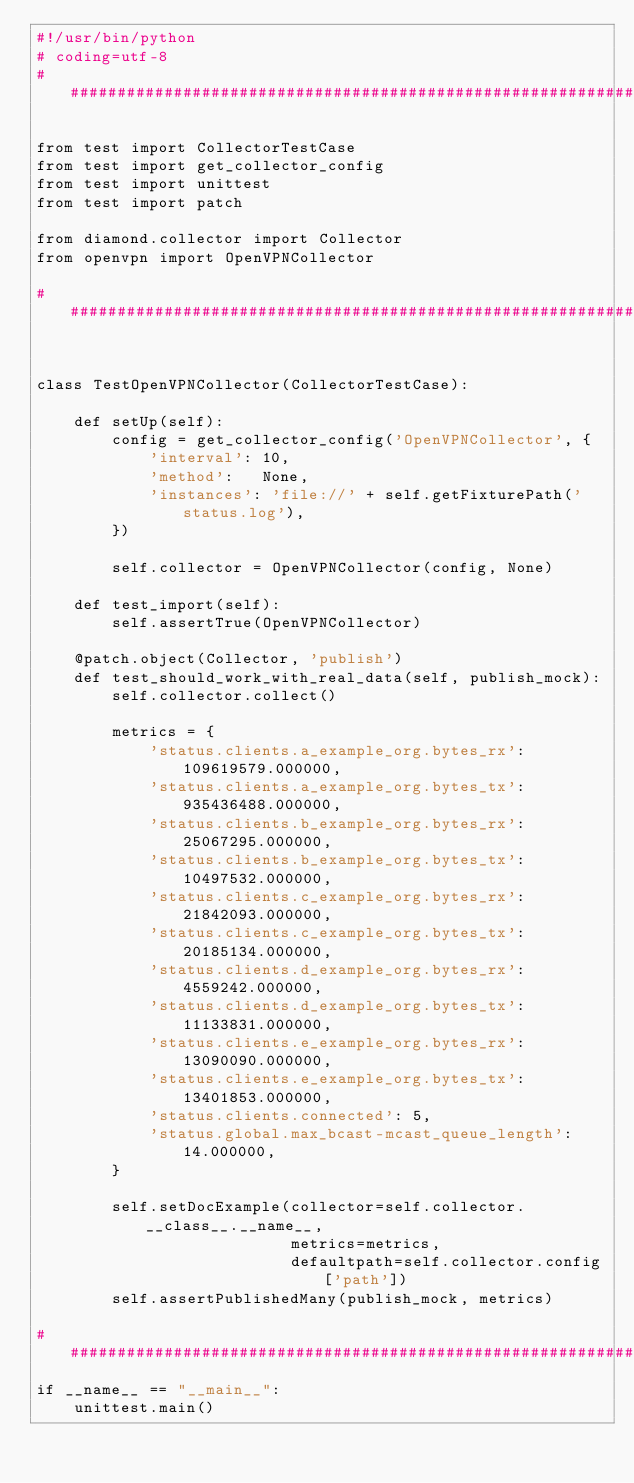<code> <loc_0><loc_0><loc_500><loc_500><_Python_>#!/usr/bin/python
# coding=utf-8
##########################################################################

from test import CollectorTestCase
from test import get_collector_config
from test import unittest
from test import patch

from diamond.collector import Collector
from openvpn import OpenVPNCollector

##########################################################################


class TestOpenVPNCollector(CollectorTestCase):

    def setUp(self):
        config = get_collector_config('OpenVPNCollector', {
            'interval': 10,
            'method':   None,
            'instances': 'file://' + self.getFixturePath('status.log'),
        })

        self.collector = OpenVPNCollector(config, None)

    def test_import(self):
        self.assertTrue(OpenVPNCollector)

    @patch.object(Collector, 'publish')
    def test_should_work_with_real_data(self, publish_mock):
        self.collector.collect()

        metrics = {
            'status.clients.a_example_org.bytes_rx': 109619579.000000,
            'status.clients.a_example_org.bytes_tx': 935436488.000000,
            'status.clients.b_example_org.bytes_rx': 25067295.000000,
            'status.clients.b_example_org.bytes_tx': 10497532.000000,
            'status.clients.c_example_org.bytes_rx': 21842093.000000,
            'status.clients.c_example_org.bytes_tx': 20185134.000000,
            'status.clients.d_example_org.bytes_rx': 4559242.000000,
            'status.clients.d_example_org.bytes_tx': 11133831.000000,
            'status.clients.e_example_org.bytes_rx': 13090090.000000,
            'status.clients.e_example_org.bytes_tx': 13401853.000000,
            'status.clients.connected': 5,
            'status.global.max_bcast-mcast_queue_length': 14.000000,
        }

        self.setDocExample(collector=self.collector.__class__.__name__,
                           metrics=metrics,
                           defaultpath=self.collector.config['path'])
        self.assertPublishedMany(publish_mock, metrics)

##########################################################################
if __name__ == "__main__":
    unittest.main()
</code> 